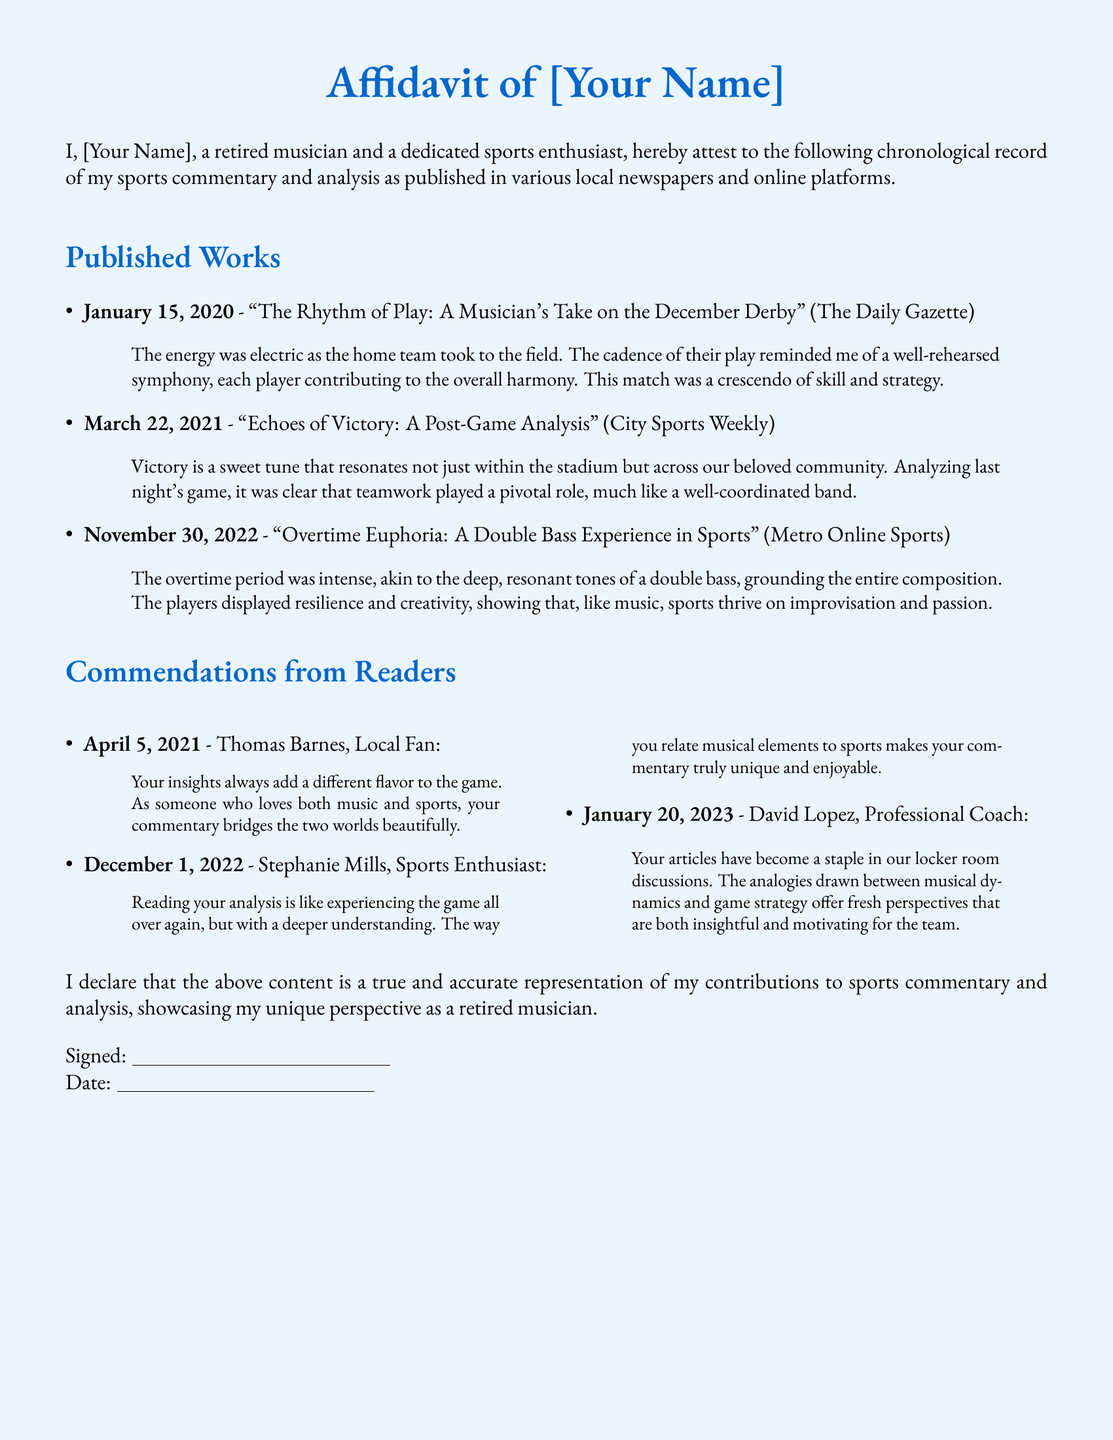What is the title of the analysis published on January 15, 2020? The title can be found under the published works section, specifically for the date January 15, 2020.
Answer: The Rhythm of Play: A Musician's Take on the December Derby Who published the work on March 22, 2021? The publisher's name is included next to the title for the analysis dated March 22, 2021.
Answer: City Sports Weekly What analogy is used in the commentary about overtime in the analysis from November 30, 2022? The analogy can be found within the quote of the analysis for that specific date.
Answer: double bass Who commended the commentary on April 5, 2021? The name of the person providing commendation is listed next to the date in the commendations section.
Answer: Thomas Barnes What is the theme of the commentary on March 22, 2021? The theme can be inferred from the title of the analysis published on that date.
Answer: teamwork How does David Lopez describe your articles? His description is found within his quote in the commendations section.
Answer: a staple in our locker room discussions What color is used for the headings in the document? The color is defined at the beginning of the document for headings and can be identified from the formatted text.
Answer: musicblue 